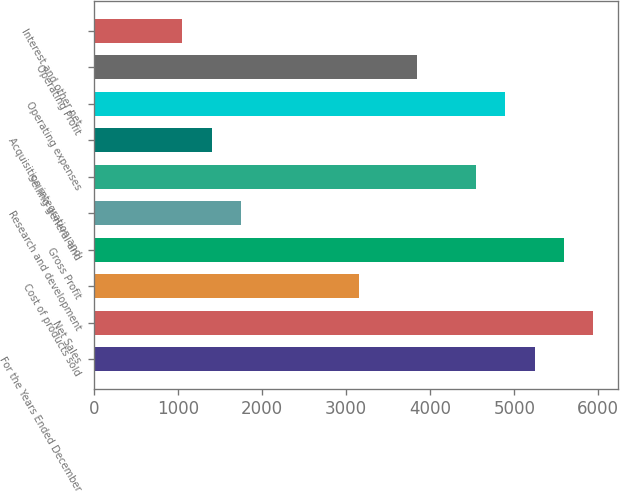<chart> <loc_0><loc_0><loc_500><loc_500><bar_chart><fcel>For the Years Ended December<fcel>Net Sales<fcel>Cost of products sold<fcel>Gross Profit<fcel>Research and development<fcel>Selling general and<fcel>Acquisition integration and<fcel>Operating expenses<fcel>Operating Profit<fcel>Interest and other net<nl><fcel>5242.85<fcel>5941.83<fcel>3145.91<fcel>5592.34<fcel>1747.95<fcel>4543.87<fcel>1398.46<fcel>4893.36<fcel>3844.89<fcel>1048.97<nl></chart> 